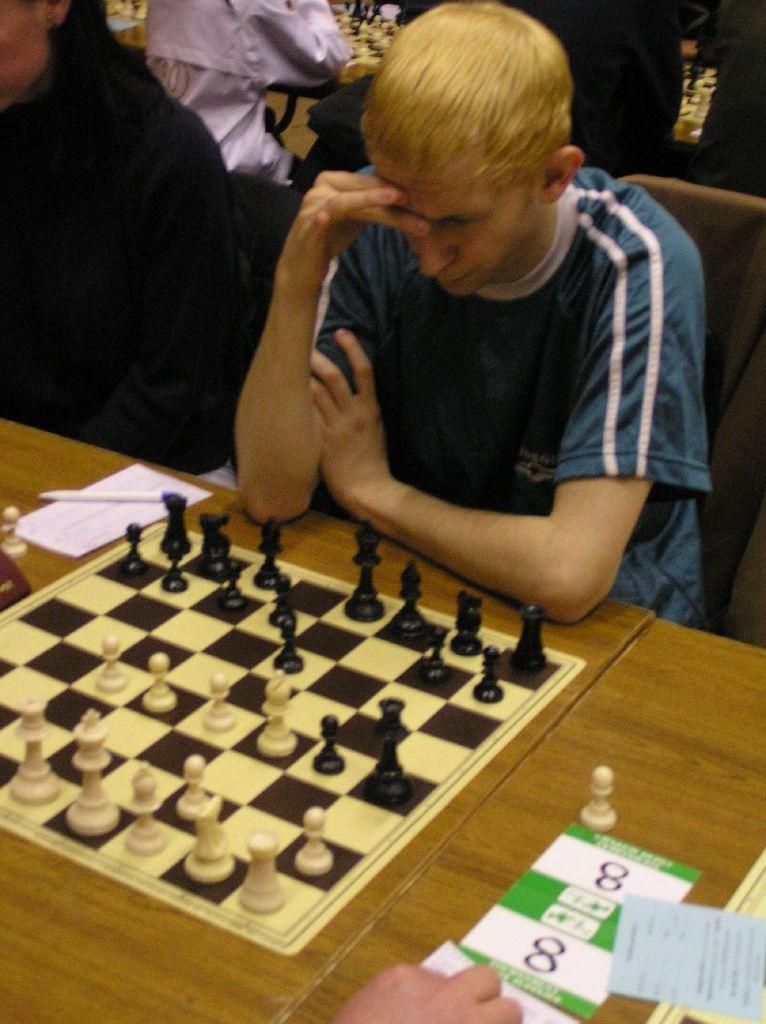What is the person in the image doing? The person is sitting on a chair in the image. Where is the person located in relation to the table? The person is in front of a table in the image. What is on the table in the image? There is a chess board on the table, as well as other objects. What type of amusement can be seen in the middle of the stocking in the image? There is no amusement or stocking present in the image. 